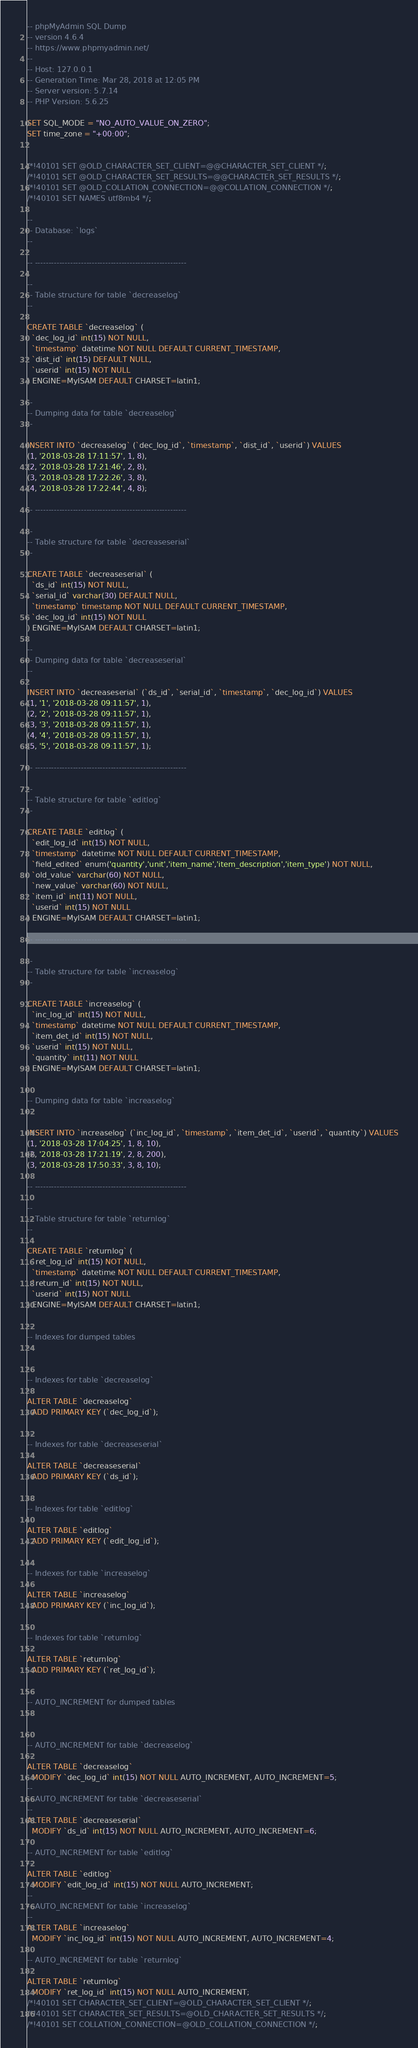Convert code to text. <code><loc_0><loc_0><loc_500><loc_500><_SQL_>-- phpMyAdmin SQL Dump
-- version 4.6.4
-- https://www.phpmyadmin.net/
--
-- Host: 127.0.0.1
-- Generation Time: Mar 28, 2018 at 12:05 PM
-- Server version: 5.7.14
-- PHP Version: 5.6.25

SET SQL_MODE = "NO_AUTO_VALUE_ON_ZERO";
SET time_zone = "+00:00";


/*!40101 SET @OLD_CHARACTER_SET_CLIENT=@@CHARACTER_SET_CLIENT */;
/*!40101 SET @OLD_CHARACTER_SET_RESULTS=@@CHARACTER_SET_RESULTS */;
/*!40101 SET @OLD_COLLATION_CONNECTION=@@COLLATION_CONNECTION */;
/*!40101 SET NAMES utf8mb4 */;

--
-- Database: `logs`
--

-- --------------------------------------------------------

--
-- Table structure for table `decreaselog`
--

CREATE TABLE `decreaselog` (
  `dec_log_id` int(15) NOT NULL,
  `timestamp` datetime NOT NULL DEFAULT CURRENT_TIMESTAMP,
  `dist_id` int(15) DEFAULT NULL,
  `userid` int(15) NOT NULL
) ENGINE=MyISAM DEFAULT CHARSET=latin1;

--
-- Dumping data for table `decreaselog`
--

INSERT INTO `decreaselog` (`dec_log_id`, `timestamp`, `dist_id`, `userid`) VALUES
(1, '2018-03-28 17:11:57', 1, 8),
(2, '2018-03-28 17:21:46', 2, 8),
(3, '2018-03-28 17:22:26', 3, 8),
(4, '2018-03-28 17:22:44', 4, 8);

-- --------------------------------------------------------

--
-- Table structure for table `decreaseserial`
--

CREATE TABLE `decreaseserial` (
  `ds_id` int(15) NOT NULL,
  `serial_id` varchar(30) DEFAULT NULL,
  `timestamp` timestamp NOT NULL DEFAULT CURRENT_TIMESTAMP,
  `dec_log_id` int(15) NOT NULL
) ENGINE=MyISAM DEFAULT CHARSET=latin1;

--
-- Dumping data for table `decreaseserial`
--

INSERT INTO `decreaseserial` (`ds_id`, `serial_id`, `timestamp`, `dec_log_id`) VALUES
(1, '1', '2018-03-28 09:11:57', 1),
(2, '2', '2018-03-28 09:11:57', 1),
(3, '3', '2018-03-28 09:11:57', 1),
(4, '4', '2018-03-28 09:11:57', 1),
(5, '5', '2018-03-28 09:11:57', 1);

-- --------------------------------------------------------

--
-- Table structure for table `editlog`
--

CREATE TABLE `editlog` (
  `edit_log_id` int(15) NOT NULL,
  `timestamp` datetime NOT NULL DEFAULT CURRENT_TIMESTAMP,
  `field_edited` enum('quantity','unit','item_name','item_description','item_type') NOT NULL,
  `old_value` varchar(60) NOT NULL,
  `new_value` varchar(60) NOT NULL,
  `item_id` int(11) NOT NULL,
  `userid` int(15) NOT NULL
) ENGINE=MyISAM DEFAULT CHARSET=latin1;

-- --------------------------------------------------------

--
-- Table structure for table `increaselog`
--

CREATE TABLE `increaselog` (
  `inc_log_id` int(15) NOT NULL,
  `timestamp` datetime NOT NULL DEFAULT CURRENT_TIMESTAMP,
  `item_det_id` int(15) NOT NULL,
  `userid` int(15) NOT NULL,
  `quantity` int(11) NOT NULL
) ENGINE=MyISAM DEFAULT CHARSET=latin1;

--
-- Dumping data for table `increaselog`
--

INSERT INTO `increaselog` (`inc_log_id`, `timestamp`, `item_det_id`, `userid`, `quantity`) VALUES
(1, '2018-03-28 17:04:25', 1, 8, 10),
(2, '2018-03-28 17:21:19', 2, 8, 200),
(3, '2018-03-28 17:50:33', 3, 8, 10);

-- --------------------------------------------------------

--
-- Table structure for table `returnlog`
--

CREATE TABLE `returnlog` (
  `ret_log_id` int(15) NOT NULL,
  `timestamp` datetime NOT NULL DEFAULT CURRENT_TIMESTAMP,
  `return_id` int(15) NOT NULL,
  `userid` int(15) NOT NULL
) ENGINE=MyISAM DEFAULT CHARSET=latin1;

--
-- Indexes for dumped tables
--

--
-- Indexes for table `decreaselog`
--
ALTER TABLE `decreaselog`
  ADD PRIMARY KEY (`dec_log_id`);

--
-- Indexes for table `decreaseserial`
--
ALTER TABLE `decreaseserial`
  ADD PRIMARY KEY (`ds_id`);

--
-- Indexes for table `editlog`
--
ALTER TABLE `editlog`
  ADD PRIMARY KEY (`edit_log_id`);

--
-- Indexes for table `increaselog`
--
ALTER TABLE `increaselog`
  ADD PRIMARY KEY (`inc_log_id`);

--
-- Indexes for table `returnlog`
--
ALTER TABLE `returnlog`
  ADD PRIMARY KEY (`ret_log_id`);

--
-- AUTO_INCREMENT for dumped tables
--

--
-- AUTO_INCREMENT for table `decreaselog`
--
ALTER TABLE `decreaselog`
  MODIFY `dec_log_id` int(15) NOT NULL AUTO_INCREMENT, AUTO_INCREMENT=5;
--
-- AUTO_INCREMENT for table `decreaseserial`
--
ALTER TABLE `decreaseserial`
  MODIFY `ds_id` int(15) NOT NULL AUTO_INCREMENT, AUTO_INCREMENT=6;
--
-- AUTO_INCREMENT for table `editlog`
--
ALTER TABLE `editlog`
  MODIFY `edit_log_id` int(15) NOT NULL AUTO_INCREMENT;
--
-- AUTO_INCREMENT for table `increaselog`
--
ALTER TABLE `increaselog`
  MODIFY `inc_log_id` int(15) NOT NULL AUTO_INCREMENT, AUTO_INCREMENT=4;
--
-- AUTO_INCREMENT for table `returnlog`
--
ALTER TABLE `returnlog`
  MODIFY `ret_log_id` int(15) NOT NULL AUTO_INCREMENT;
/*!40101 SET CHARACTER_SET_CLIENT=@OLD_CHARACTER_SET_CLIENT */;
/*!40101 SET CHARACTER_SET_RESULTS=@OLD_CHARACTER_SET_RESULTS */;
/*!40101 SET COLLATION_CONNECTION=@OLD_COLLATION_CONNECTION */;
</code> 